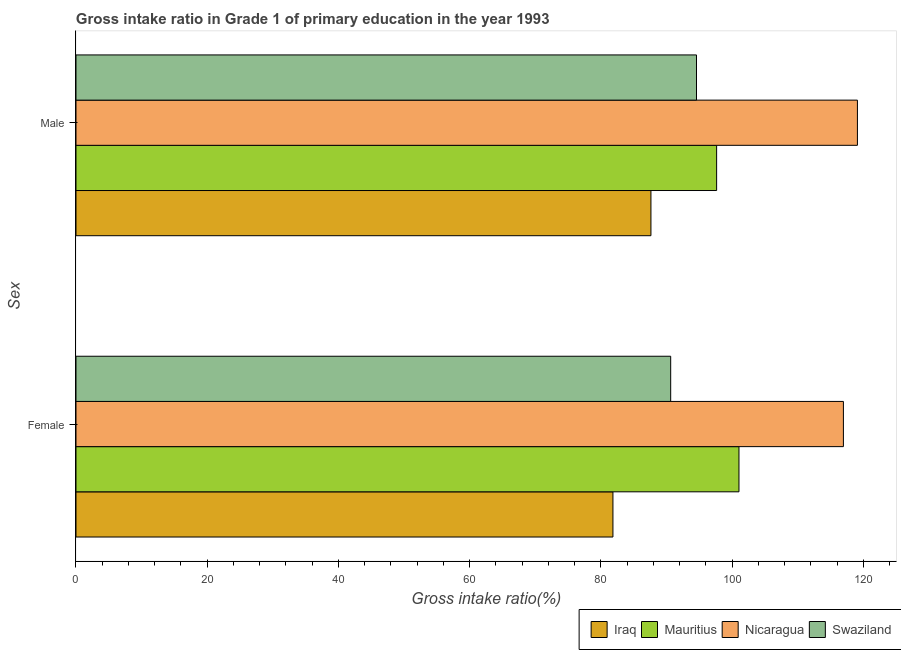Are the number of bars per tick equal to the number of legend labels?
Provide a short and direct response. Yes. Are the number of bars on each tick of the Y-axis equal?
Give a very brief answer. Yes. How many bars are there on the 1st tick from the bottom?
Offer a very short reply. 4. What is the gross intake ratio(female) in Nicaragua?
Your response must be concise. 116.95. Across all countries, what is the maximum gross intake ratio(male)?
Your answer should be compact. 119.08. Across all countries, what is the minimum gross intake ratio(female)?
Give a very brief answer. 81.83. In which country was the gross intake ratio(male) maximum?
Give a very brief answer. Nicaragua. In which country was the gross intake ratio(male) minimum?
Provide a succinct answer. Iraq. What is the total gross intake ratio(female) in the graph?
Your answer should be very brief. 390.43. What is the difference between the gross intake ratio(female) in Swaziland and that in Iraq?
Keep it short and to the point. 8.8. What is the difference between the gross intake ratio(male) in Swaziland and the gross intake ratio(female) in Nicaragua?
Keep it short and to the point. -22.39. What is the average gross intake ratio(male) per country?
Your answer should be compact. 99.72. What is the difference between the gross intake ratio(female) and gross intake ratio(male) in Iraq?
Your answer should be compact. -5.79. What is the ratio of the gross intake ratio(female) in Nicaragua to that in Mauritius?
Keep it short and to the point. 1.16. What does the 2nd bar from the top in Male represents?
Ensure brevity in your answer.  Nicaragua. What does the 1st bar from the bottom in Male represents?
Your answer should be compact. Iraq. How many bars are there?
Give a very brief answer. 8. Are all the bars in the graph horizontal?
Your answer should be compact. Yes. Where does the legend appear in the graph?
Provide a short and direct response. Bottom right. What is the title of the graph?
Make the answer very short. Gross intake ratio in Grade 1 of primary education in the year 1993. Does "Germany" appear as one of the legend labels in the graph?
Your answer should be compact. No. What is the label or title of the X-axis?
Your response must be concise. Gross intake ratio(%). What is the label or title of the Y-axis?
Offer a very short reply. Sex. What is the Gross intake ratio(%) of Iraq in Female?
Offer a terse response. 81.83. What is the Gross intake ratio(%) of Mauritius in Female?
Make the answer very short. 101.03. What is the Gross intake ratio(%) of Nicaragua in Female?
Provide a short and direct response. 116.95. What is the Gross intake ratio(%) in Swaziland in Female?
Provide a short and direct response. 90.63. What is the Gross intake ratio(%) of Iraq in Male?
Ensure brevity in your answer.  87.62. What is the Gross intake ratio(%) in Mauritius in Male?
Offer a very short reply. 97.63. What is the Gross intake ratio(%) of Nicaragua in Male?
Provide a succinct answer. 119.08. What is the Gross intake ratio(%) in Swaziland in Male?
Keep it short and to the point. 94.56. Across all Sex, what is the maximum Gross intake ratio(%) of Iraq?
Provide a short and direct response. 87.62. Across all Sex, what is the maximum Gross intake ratio(%) of Mauritius?
Provide a succinct answer. 101.03. Across all Sex, what is the maximum Gross intake ratio(%) of Nicaragua?
Your answer should be very brief. 119.08. Across all Sex, what is the maximum Gross intake ratio(%) in Swaziland?
Make the answer very short. 94.56. Across all Sex, what is the minimum Gross intake ratio(%) in Iraq?
Your answer should be compact. 81.83. Across all Sex, what is the minimum Gross intake ratio(%) in Mauritius?
Give a very brief answer. 97.63. Across all Sex, what is the minimum Gross intake ratio(%) in Nicaragua?
Keep it short and to the point. 116.95. Across all Sex, what is the minimum Gross intake ratio(%) of Swaziland?
Your response must be concise. 90.63. What is the total Gross intake ratio(%) in Iraq in the graph?
Offer a terse response. 169.44. What is the total Gross intake ratio(%) of Mauritius in the graph?
Provide a short and direct response. 198.66. What is the total Gross intake ratio(%) of Nicaragua in the graph?
Your answer should be very brief. 236.03. What is the total Gross intake ratio(%) of Swaziland in the graph?
Your answer should be compact. 185.19. What is the difference between the Gross intake ratio(%) of Iraq in Female and that in Male?
Make the answer very short. -5.79. What is the difference between the Gross intake ratio(%) of Mauritius in Female and that in Male?
Offer a terse response. 3.41. What is the difference between the Gross intake ratio(%) in Nicaragua in Female and that in Male?
Provide a succinct answer. -2.14. What is the difference between the Gross intake ratio(%) of Swaziland in Female and that in Male?
Make the answer very short. -3.93. What is the difference between the Gross intake ratio(%) in Iraq in Female and the Gross intake ratio(%) in Mauritius in Male?
Provide a succinct answer. -15.8. What is the difference between the Gross intake ratio(%) of Iraq in Female and the Gross intake ratio(%) of Nicaragua in Male?
Provide a succinct answer. -37.26. What is the difference between the Gross intake ratio(%) in Iraq in Female and the Gross intake ratio(%) in Swaziland in Male?
Keep it short and to the point. -12.73. What is the difference between the Gross intake ratio(%) of Mauritius in Female and the Gross intake ratio(%) of Nicaragua in Male?
Your answer should be very brief. -18.05. What is the difference between the Gross intake ratio(%) of Mauritius in Female and the Gross intake ratio(%) of Swaziland in Male?
Offer a very short reply. 6.47. What is the difference between the Gross intake ratio(%) of Nicaragua in Female and the Gross intake ratio(%) of Swaziland in Male?
Ensure brevity in your answer.  22.39. What is the average Gross intake ratio(%) of Iraq per Sex?
Give a very brief answer. 84.72. What is the average Gross intake ratio(%) of Mauritius per Sex?
Keep it short and to the point. 99.33. What is the average Gross intake ratio(%) in Nicaragua per Sex?
Offer a terse response. 118.01. What is the average Gross intake ratio(%) of Swaziland per Sex?
Ensure brevity in your answer.  92.59. What is the difference between the Gross intake ratio(%) of Iraq and Gross intake ratio(%) of Mauritius in Female?
Provide a succinct answer. -19.21. What is the difference between the Gross intake ratio(%) in Iraq and Gross intake ratio(%) in Nicaragua in Female?
Keep it short and to the point. -35.12. What is the difference between the Gross intake ratio(%) of Iraq and Gross intake ratio(%) of Swaziland in Female?
Your response must be concise. -8.8. What is the difference between the Gross intake ratio(%) in Mauritius and Gross intake ratio(%) in Nicaragua in Female?
Ensure brevity in your answer.  -15.91. What is the difference between the Gross intake ratio(%) of Mauritius and Gross intake ratio(%) of Swaziland in Female?
Provide a succinct answer. 10.41. What is the difference between the Gross intake ratio(%) of Nicaragua and Gross intake ratio(%) of Swaziland in Female?
Make the answer very short. 26.32. What is the difference between the Gross intake ratio(%) of Iraq and Gross intake ratio(%) of Mauritius in Male?
Offer a very short reply. -10.01. What is the difference between the Gross intake ratio(%) of Iraq and Gross intake ratio(%) of Nicaragua in Male?
Offer a terse response. -31.47. What is the difference between the Gross intake ratio(%) in Iraq and Gross intake ratio(%) in Swaziland in Male?
Give a very brief answer. -6.94. What is the difference between the Gross intake ratio(%) of Mauritius and Gross intake ratio(%) of Nicaragua in Male?
Ensure brevity in your answer.  -21.46. What is the difference between the Gross intake ratio(%) of Mauritius and Gross intake ratio(%) of Swaziland in Male?
Ensure brevity in your answer.  3.07. What is the difference between the Gross intake ratio(%) of Nicaragua and Gross intake ratio(%) of Swaziland in Male?
Offer a very short reply. 24.52. What is the ratio of the Gross intake ratio(%) of Iraq in Female to that in Male?
Provide a short and direct response. 0.93. What is the ratio of the Gross intake ratio(%) of Mauritius in Female to that in Male?
Keep it short and to the point. 1.03. What is the ratio of the Gross intake ratio(%) of Nicaragua in Female to that in Male?
Your answer should be very brief. 0.98. What is the ratio of the Gross intake ratio(%) in Swaziland in Female to that in Male?
Give a very brief answer. 0.96. What is the difference between the highest and the second highest Gross intake ratio(%) in Iraq?
Provide a short and direct response. 5.79. What is the difference between the highest and the second highest Gross intake ratio(%) in Mauritius?
Make the answer very short. 3.41. What is the difference between the highest and the second highest Gross intake ratio(%) in Nicaragua?
Your answer should be compact. 2.14. What is the difference between the highest and the second highest Gross intake ratio(%) in Swaziland?
Make the answer very short. 3.93. What is the difference between the highest and the lowest Gross intake ratio(%) of Iraq?
Offer a very short reply. 5.79. What is the difference between the highest and the lowest Gross intake ratio(%) of Mauritius?
Provide a succinct answer. 3.41. What is the difference between the highest and the lowest Gross intake ratio(%) of Nicaragua?
Your response must be concise. 2.14. What is the difference between the highest and the lowest Gross intake ratio(%) in Swaziland?
Your answer should be very brief. 3.93. 